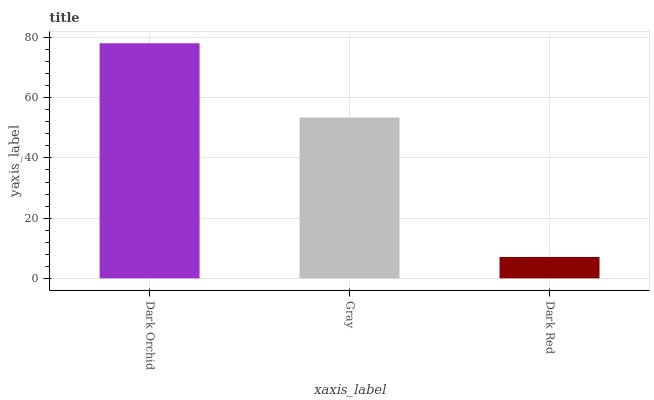Is Dark Red the minimum?
Answer yes or no. Yes. Is Dark Orchid the maximum?
Answer yes or no. Yes. Is Gray the minimum?
Answer yes or no. No. Is Gray the maximum?
Answer yes or no. No. Is Dark Orchid greater than Gray?
Answer yes or no. Yes. Is Gray less than Dark Orchid?
Answer yes or no. Yes. Is Gray greater than Dark Orchid?
Answer yes or no. No. Is Dark Orchid less than Gray?
Answer yes or no. No. Is Gray the high median?
Answer yes or no. Yes. Is Gray the low median?
Answer yes or no. Yes. Is Dark Orchid the high median?
Answer yes or no. No. Is Dark Red the low median?
Answer yes or no. No. 